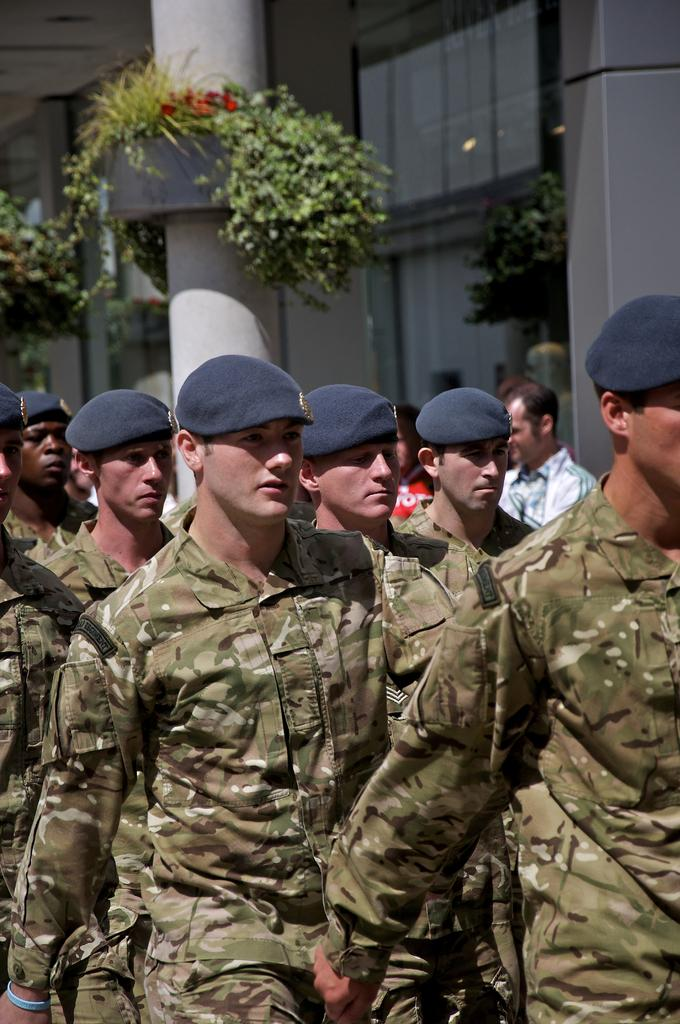What is the main subject of the image? The main subject of the image is a group of men standing. What architectural features can be seen in the image? There are pillars visible in the image. What type of vegetation is present in the image? There are plants in the image. What type of structure is depicted in the image? There is a building in the image. Can you tell me where the mom is sitting in the image? There is no mom present in the image; it features a group of men standing. How many times does the sheet appear in the image? There is no sheet present in the image. 